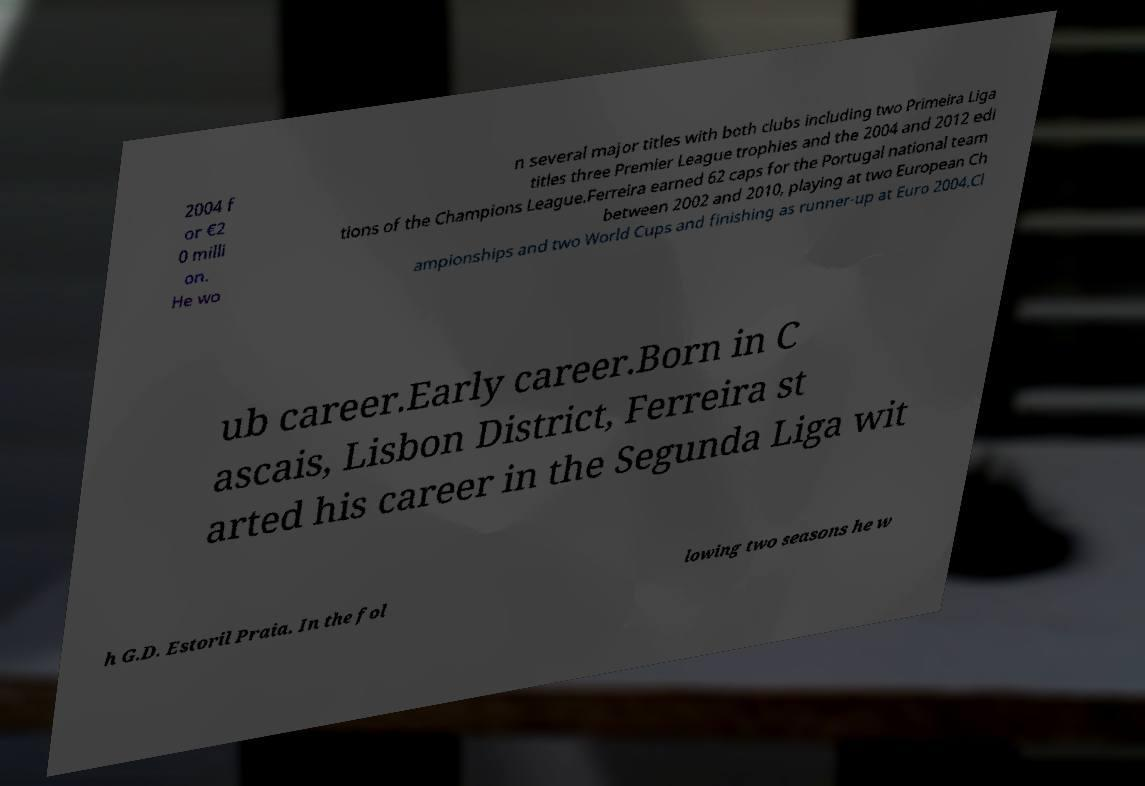Please identify and transcribe the text found in this image. 2004 f or €2 0 milli on. He wo n several major titles with both clubs including two Primeira Liga titles three Premier League trophies and the 2004 and 2012 edi tions of the Champions League.Ferreira earned 62 caps for the Portugal national team between 2002 and 2010, playing at two European Ch ampionships and two World Cups and finishing as runner-up at Euro 2004.Cl ub career.Early career.Born in C ascais, Lisbon District, Ferreira st arted his career in the Segunda Liga wit h G.D. Estoril Praia. In the fol lowing two seasons he w 